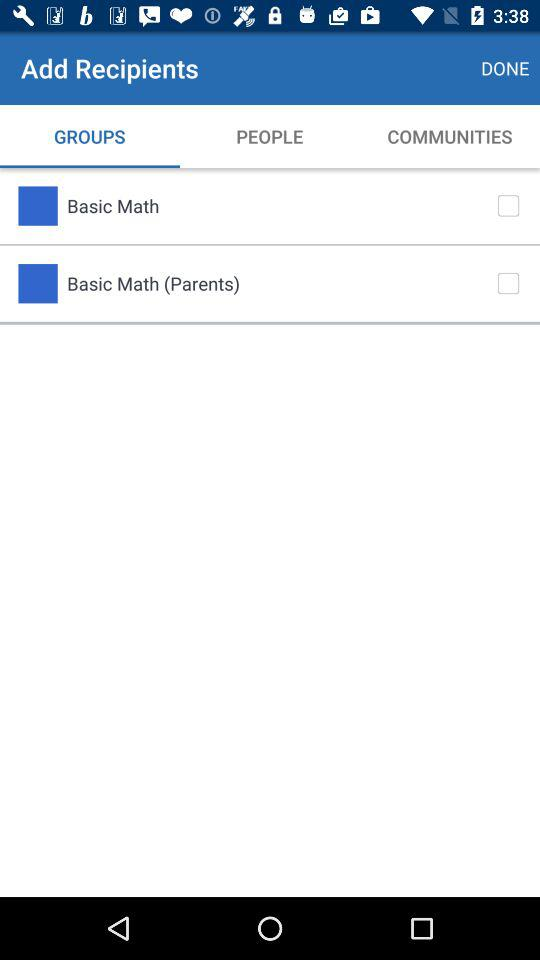Which tab am I on? You are on "GROUPS" tab. 